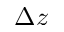<formula> <loc_0><loc_0><loc_500><loc_500>\Delta z</formula> 